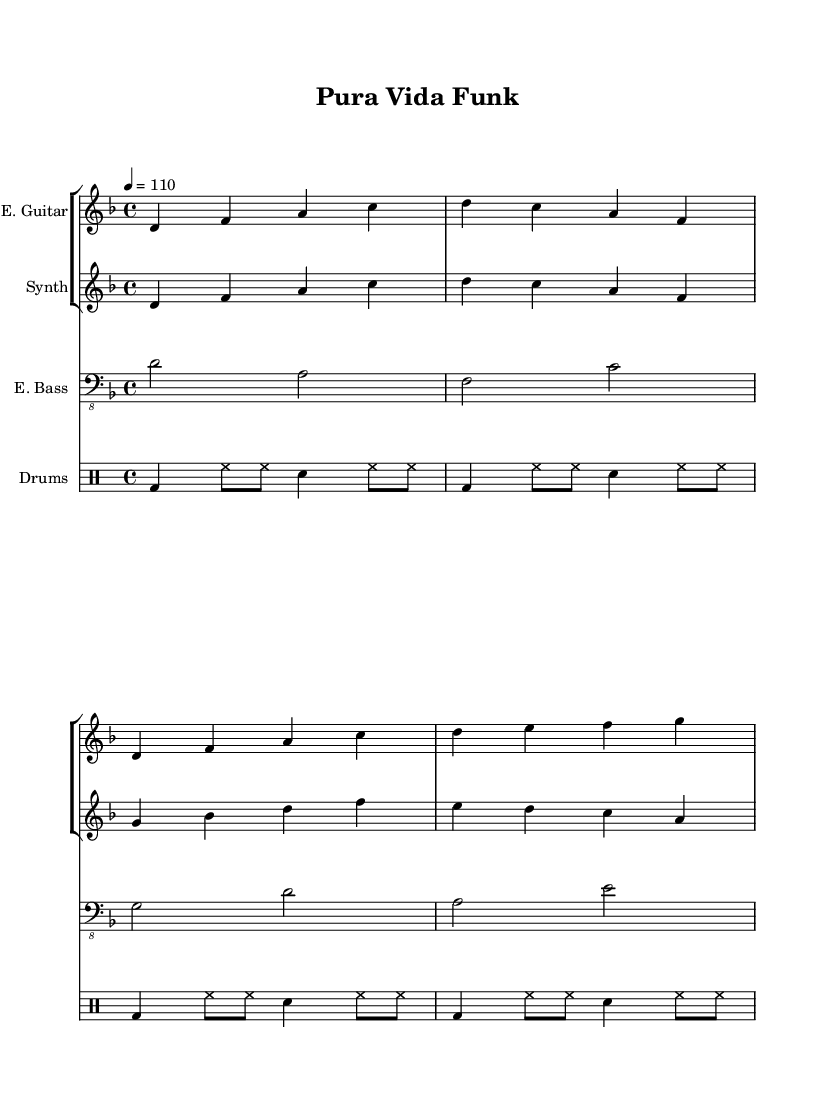What is the key signature of this music? The key signature indicated at the beginning of the score is D minor, which has one flat (B♭). This can be determined by looking at the key signature symbols on the staff.
Answer: D minor What is the time signature of this piece? The time signature is located at the beginning of the score, indicated as 4/4. This means there are four beats in each measure, and the quarter note receives one beat.
Answer: 4/4 What is the tempo marking for this composition? The tempo marking is shown at the beginning of the score and indicates a speed of 110 beats per minute, written as "4 = 110". This indicates the metronome marking for the piece.
Answer: 110 How many measures are there in the electric bass part? By counting the measure bars in the electric bass staff, there are four measures of music present. Each vertical bar line represents a measure, and there are four such lines.
Answer: 4 Which instrument is playing the highest notes in this score? By comparing the ranges of the instruments in the score, the synthesizer plays the highest notes, reaching higher pitches compared to the electric guitar and bass, which play lower notes in their registers.
Answer: Synthesizer What rhythmic pattern is played by the drum kit? The drum part consists of a repeating pattern of bass drum (bd), hi-hat (hh), and snare (sn) across each measure. The pattern repeats consistently throughout the score, showing a common funk rhythm.
Answer: Funk rhythm What unique feature does this piece exhibit that relates to its genre? The piece incorporates electronic elements through the use of synthesizers alongside traditional funk instrumentation like the electric guitar and bass, which is characteristic of experimental funk.
Answer: Electronic elements 